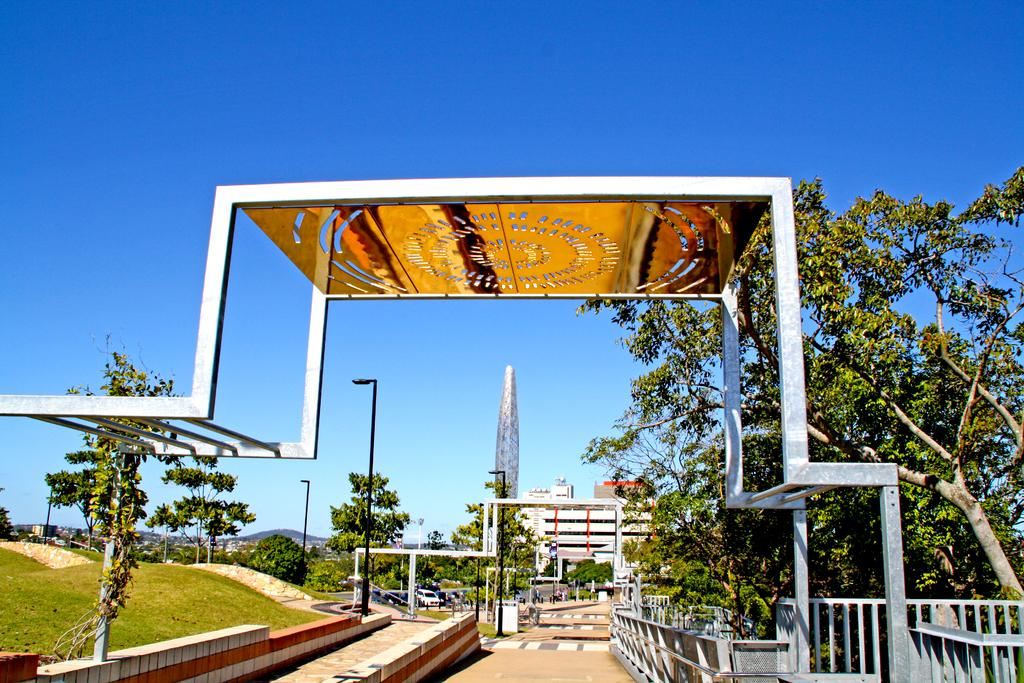What type of vegetation is present in the image? There is grass in the image. What other natural elements can be seen in the image? There are trees in the image. What type of artificial lighting is present in the image? There are street lamps in the image. What type of man-made structures are present in the image? There are buildings in the image. What type of vehicles are present in the image? There are cars in the image. What color is the sky in the image? The sky is blue in the image. What disease is being discussed by the trees in the image? There is no indication in the image that the trees are discussing any disease. What is the end result of the conversation between the cars in the image? There is no conversation between the cars in the image, as cars do not have the ability to talk. 